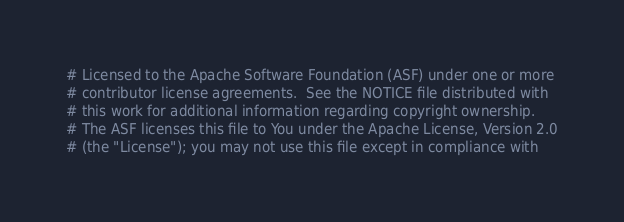<code> <loc_0><loc_0><loc_500><loc_500><_Python_># Licensed to the Apache Software Foundation (ASF) under one or more
# contributor license agreements.  See the NOTICE file distributed with
# this work for additional information regarding copyright ownership.
# The ASF licenses this file to You under the Apache License, Version 2.0
# (the "License"); you may not use this file except in compliance with</code> 